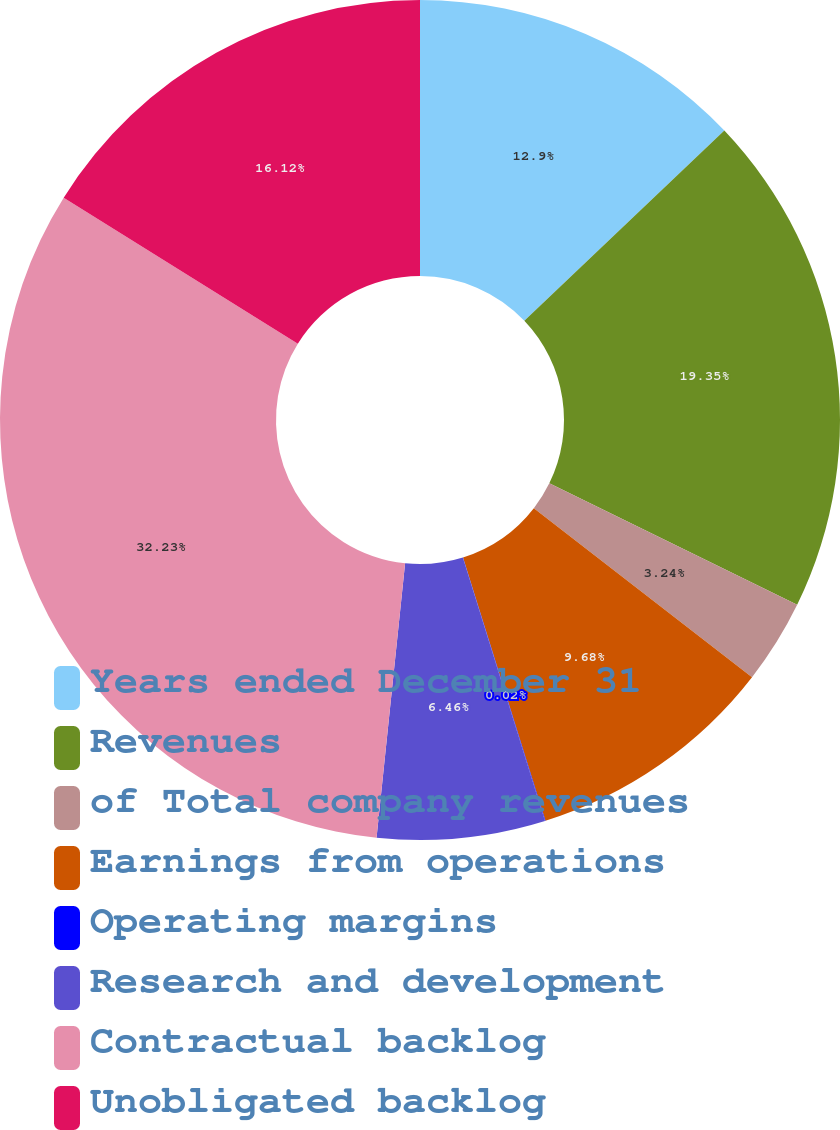<chart> <loc_0><loc_0><loc_500><loc_500><pie_chart><fcel>Years ended December 31<fcel>Revenues<fcel>of Total company revenues<fcel>Earnings from operations<fcel>Operating margins<fcel>Research and development<fcel>Contractual backlog<fcel>Unobligated backlog<nl><fcel>12.9%<fcel>19.35%<fcel>3.24%<fcel>9.68%<fcel>0.02%<fcel>6.46%<fcel>32.23%<fcel>16.12%<nl></chart> 